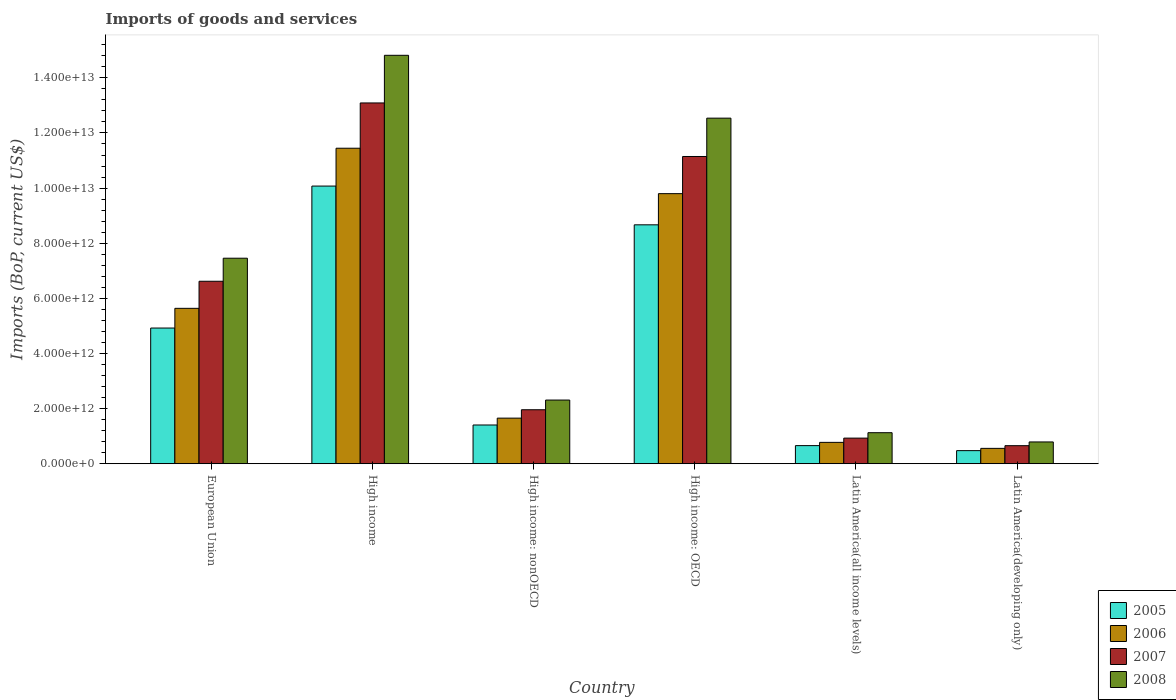How many groups of bars are there?
Provide a succinct answer. 6. Are the number of bars per tick equal to the number of legend labels?
Make the answer very short. Yes. How many bars are there on the 6th tick from the right?
Your answer should be very brief. 4. What is the label of the 6th group of bars from the left?
Keep it short and to the point. Latin America(developing only). What is the amount spent on imports in 2006 in European Union?
Keep it short and to the point. 5.64e+12. Across all countries, what is the maximum amount spent on imports in 2008?
Offer a terse response. 1.48e+13. Across all countries, what is the minimum amount spent on imports in 2005?
Ensure brevity in your answer.  4.75e+11. In which country was the amount spent on imports in 2005 minimum?
Your response must be concise. Latin America(developing only). What is the total amount spent on imports in 2008 in the graph?
Offer a very short reply. 3.90e+13. What is the difference between the amount spent on imports in 2005 in High income: OECD and that in Latin America(all income levels)?
Ensure brevity in your answer.  8.01e+12. What is the difference between the amount spent on imports in 2008 in High income: nonOECD and the amount spent on imports in 2006 in Latin America(developing only)?
Give a very brief answer. 1.75e+12. What is the average amount spent on imports in 2005 per country?
Provide a succinct answer. 4.37e+12. What is the difference between the amount spent on imports of/in 2007 and amount spent on imports of/in 2008 in High income?
Offer a terse response. -1.73e+12. What is the ratio of the amount spent on imports in 2008 in European Union to that in High income: nonOECD?
Offer a very short reply. 3.23. What is the difference between the highest and the second highest amount spent on imports in 2008?
Offer a very short reply. 7.36e+12. What is the difference between the highest and the lowest amount spent on imports in 2007?
Provide a short and direct response. 1.24e+13. What does the 1st bar from the left in Latin America(developing only) represents?
Offer a terse response. 2005. How many countries are there in the graph?
Your answer should be very brief. 6. What is the difference between two consecutive major ticks on the Y-axis?
Keep it short and to the point. 2.00e+12. Does the graph contain any zero values?
Give a very brief answer. No. How are the legend labels stacked?
Your answer should be compact. Vertical. What is the title of the graph?
Your answer should be very brief. Imports of goods and services. Does "1988" appear as one of the legend labels in the graph?
Offer a terse response. No. What is the label or title of the Y-axis?
Ensure brevity in your answer.  Imports (BoP, current US$). What is the Imports (BoP, current US$) of 2005 in European Union?
Your answer should be compact. 4.92e+12. What is the Imports (BoP, current US$) in 2006 in European Union?
Your response must be concise. 5.64e+12. What is the Imports (BoP, current US$) of 2007 in European Union?
Your answer should be very brief. 6.62e+12. What is the Imports (BoP, current US$) in 2008 in European Union?
Provide a succinct answer. 7.46e+12. What is the Imports (BoP, current US$) of 2005 in High income?
Offer a terse response. 1.01e+13. What is the Imports (BoP, current US$) in 2006 in High income?
Ensure brevity in your answer.  1.14e+13. What is the Imports (BoP, current US$) of 2007 in High income?
Provide a succinct answer. 1.31e+13. What is the Imports (BoP, current US$) in 2008 in High income?
Make the answer very short. 1.48e+13. What is the Imports (BoP, current US$) of 2005 in High income: nonOECD?
Provide a succinct answer. 1.41e+12. What is the Imports (BoP, current US$) in 2006 in High income: nonOECD?
Provide a short and direct response. 1.65e+12. What is the Imports (BoP, current US$) in 2007 in High income: nonOECD?
Make the answer very short. 1.96e+12. What is the Imports (BoP, current US$) in 2008 in High income: nonOECD?
Your answer should be compact. 2.31e+12. What is the Imports (BoP, current US$) in 2005 in High income: OECD?
Offer a terse response. 8.67e+12. What is the Imports (BoP, current US$) in 2006 in High income: OECD?
Provide a short and direct response. 9.80e+12. What is the Imports (BoP, current US$) of 2007 in High income: OECD?
Your answer should be compact. 1.11e+13. What is the Imports (BoP, current US$) in 2008 in High income: OECD?
Make the answer very short. 1.25e+13. What is the Imports (BoP, current US$) of 2005 in Latin America(all income levels)?
Keep it short and to the point. 6.57e+11. What is the Imports (BoP, current US$) of 2006 in Latin America(all income levels)?
Make the answer very short. 7.75e+11. What is the Imports (BoP, current US$) in 2007 in Latin America(all income levels)?
Make the answer very short. 9.30e+11. What is the Imports (BoP, current US$) in 2008 in Latin America(all income levels)?
Provide a succinct answer. 1.13e+12. What is the Imports (BoP, current US$) in 2005 in Latin America(developing only)?
Make the answer very short. 4.75e+11. What is the Imports (BoP, current US$) of 2006 in Latin America(developing only)?
Keep it short and to the point. 5.57e+11. What is the Imports (BoP, current US$) in 2007 in Latin America(developing only)?
Your response must be concise. 6.55e+11. What is the Imports (BoP, current US$) of 2008 in Latin America(developing only)?
Offer a very short reply. 7.91e+11. Across all countries, what is the maximum Imports (BoP, current US$) in 2005?
Provide a succinct answer. 1.01e+13. Across all countries, what is the maximum Imports (BoP, current US$) in 2006?
Provide a short and direct response. 1.14e+13. Across all countries, what is the maximum Imports (BoP, current US$) of 2007?
Your response must be concise. 1.31e+13. Across all countries, what is the maximum Imports (BoP, current US$) in 2008?
Make the answer very short. 1.48e+13. Across all countries, what is the minimum Imports (BoP, current US$) of 2005?
Give a very brief answer. 4.75e+11. Across all countries, what is the minimum Imports (BoP, current US$) of 2006?
Make the answer very short. 5.57e+11. Across all countries, what is the minimum Imports (BoP, current US$) in 2007?
Your answer should be very brief. 6.55e+11. Across all countries, what is the minimum Imports (BoP, current US$) in 2008?
Offer a very short reply. 7.91e+11. What is the total Imports (BoP, current US$) of 2005 in the graph?
Make the answer very short. 2.62e+13. What is the total Imports (BoP, current US$) of 2006 in the graph?
Ensure brevity in your answer.  2.99e+13. What is the total Imports (BoP, current US$) in 2007 in the graph?
Ensure brevity in your answer.  3.44e+13. What is the total Imports (BoP, current US$) of 2008 in the graph?
Ensure brevity in your answer.  3.90e+13. What is the difference between the Imports (BoP, current US$) in 2005 in European Union and that in High income?
Provide a succinct answer. -5.15e+12. What is the difference between the Imports (BoP, current US$) in 2006 in European Union and that in High income?
Keep it short and to the point. -5.81e+12. What is the difference between the Imports (BoP, current US$) of 2007 in European Union and that in High income?
Offer a very short reply. -6.47e+12. What is the difference between the Imports (BoP, current US$) of 2008 in European Union and that in High income?
Give a very brief answer. -7.36e+12. What is the difference between the Imports (BoP, current US$) in 2005 in European Union and that in High income: nonOECD?
Offer a terse response. 3.52e+12. What is the difference between the Imports (BoP, current US$) of 2006 in European Union and that in High income: nonOECD?
Keep it short and to the point. 3.98e+12. What is the difference between the Imports (BoP, current US$) in 2007 in European Union and that in High income: nonOECD?
Make the answer very short. 4.66e+12. What is the difference between the Imports (BoP, current US$) of 2008 in European Union and that in High income: nonOECD?
Give a very brief answer. 5.15e+12. What is the difference between the Imports (BoP, current US$) in 2005 in European Union and that in High income: OECD?
Offer a terse response. -3.74e+12. What is the difference between the Imports (BoP, current US$) in 2006 in European Union and that in High income: OECD?
Offer a very short reply. -4.16e+12. What is the difference between the Imports (BoP, current US$) of 2007 in European Union and that in High income: OECD?
Your response must be concise. -4.53e+12. What is the difference between the Imports (BoP, current US$) in 2008 in European Union and that in High income: OECD?
Provide a short and direct response. -5.08e+12. What is the difference between the Imports (BoP, current US$) in 2005 in European Union and that in Latin America(all income levels)?
Offer a very short reply. 4.27e+12. What is the difference between the Imports (BoP, current US$) of 2006 in European Union and that in Latin America(all income levels)?
Provide a succinct answer. 4.86e+12. What is the difference between the Imports (BoP, current US$) of 2007 in European Union and that in Latin America(all income levels)?
Make the answer very short. 5.69e+12. What is the difference between the Imports (BoP, current US$) of 2008 in European Union and that in Latin America(all income levels)?
Keep it short and to the point. 6.33e+12. What is the difference between the Imports (BoP, current US$) in 2005 in European Union and that in Latin America(developing only)?
Provide a short and direct response. 4.45e+12. What is the difference between the Imports (BoP, current US$) in 2006 in European Union and that in Latin America(developing only)?
Offer a very short reply. 5.08e+12. What is the difference between the Imports (BoP, current US$) of 2007 in European Union and that in Latin America(developing only)?
Provide a short and direct response. 5.96e+12. What is the difference between the Imports (BoP, current US$) in 2008 in European Union and that in Latin America(developing only)?
Your response must be concise. 6.67e+12. What is the difference between the Imports (BoP, current US$) of 2005 in High income and that in High income: nonOECD?
Provide a short and direct response. 8.67e+12. What is the difference between the Imports (BoP, current US$) of 2006 in High income and that in High income: nonOECD?
Ensure brevity in your answer.  9.79e+12. What is the difference between the Imports (BoP, current US$) in 2007 in High income and that in High income: nonOECD?
Your answer should be compact. 1.11e+13. What is the difference between the Imports (BoP, current US$) of 2008 in High income and that in High income: nonOECD?
Ensure brevity in your answer.  1.25e+13. What is the difference between the Imports (BoP, current US$) in 2005 in High income and that in High income: OECD?
Offer a terse response. 1.41e+12. What is the difference between the Imports (BoP, current US$) in 2006 in High income and that in High income: OECD?
Your answer should be very brief. 1.65e+12. What is the difference between the Imports (BoP, current US$) of 2007 in High income and that in High income: OECD?
Give a very brief answer. 1.94e+12. What is the difference between the Imports (BoP, current US$) in 2008 in High income and that in High income: OECD?
Ensure brevity in your answer.  2.28e+12. What is the difference between the Imports (BoP, current US$) in 2005 in High income and that in Latin America(all income levels)?
Offer a very short reply. 9.42e+12. What is the difference between the Imports (BoP, current US$) of 2006 in High income and that in Latin America(all income levels)?
Keep it short and to the point. 1.07e+13. What is the difference between the Imports (BoP, current US$) in 2007 in High income and that in Latin America(all income levels)?
Ensure brevity in your answer.  1.22e+13. What is the difference between the Imports (BoP, current US$) of 2008 in High income and that in Latin America(all income levels)?
Make the answer very short. 1.37e+13. What is the difference between the Imports (BoP, current US$) of 2005 in High income and that in Latin America(developing only)?
Offer a very short reply. 9.60e+12. What is the difference between the Imports (BoP, current US$) of 2006 in High income and that in Latin America(developing only)?
Your answer should be very brief. 1.09e+13. What is the difference between the Imports (BoP, current US$) of 2007 in High income and that in Latin America(developing only)?
Provide a short and direct response. 1.24e+13. What is the difference between the Imports (BoP, current US$) of 2008 in High income and that in Latin America(developing only)?
Provide a short and direct response. 1.40e+13. What is the difference between the Imports (BoP, current US$) in 2005 in High income: nonOECD and that in High income: OECD?
Give a very brief answer. -7.26e+12. What is the difference between the Imports (BoP, current US$) of 2006 in High income: nonOECD and that in High income: OECD?
Provide a short and direct response. -8.14e+12. What is the difference between the Imports (BoP, current US$) of 2007 in High income: nonOECD and that in High income: OECD?
Offer a terse response. -9.19e+12. What is the difference between the Imports (BoP, current US$) of 2008 in High income: nonOECD and that in High income: OECD?
Provide a short and direct response. -1.02e+13. What is the difference between the Imports (BoP, current US$) of 2005 in High income: nonOECD and that in Latin America(all income levels)?
Keep it short and to the point. 7.48e+11. What is the difference between the Imports (BoP, current US$) in 2006 in High income: nonOECD and that in Latin America(all income levels)?
Make the answer very short. 8.79e+11. What is the difference between the Imports (BoP, current US$) in 2007 in High income: nonOECD and that in Latin America(all income levels)?
Your answer should be very brief. 1.03e+12. What is the difference between the Imports (BoP, current US$) of 2008 in High income: nonOECD and that in Latin America(all income levels)?
Keep it short and to the point. 1.18e+12. What is the difference between the Imports (BoP, current US$) in 2005 in High income: nonOECD and that in Latin America(developing only)?
Provide a succinct answer. 9.30e+11. What is the difference between the Imports (BoP, current US$) of 2006 in High income: nonOECD and that in Latin America(developing only)?
Offer a terse response. 1.10e+12. What is the difference between the Imports (BoP, current US$) of 2007 in High income: nonOECD and that in Latin America(developing only)?
Offer a terse response. 1.30e+12. What is the difference between the Imports (BoP, current US$) in 2008 in High income: nonOECD and that in Latin America(developing only)?
Provide a short and direct response. 1.52e+12. What is the difference between the Imports (BoP, current US$) in 2005 in High income: OECD and that in Latin America(all income levels)?
Your answer should be compact. 8.01e+12. What is the difference between the Imports (BoP, current US$) of 2006 in High income: OECD and that in Latin America(all income levels)?
Offer a very short reply. 9.02e+12. What is the difference between the Imports (BoP, current US$) in 2007 in High income: OECD and that in Latin America(all income levels)?
Make the answer very short. 1.02e+13. What is the difference between the Imports (BoP, current US$) of 2008 in High income: OECD and that in Latin America(all income levels)?
Ensure brevity in your answer.  1.14e+13. What is the difference between the Imports (BoP, current US$) of 2005 in High income: OECD and that in Latin America(developing only)?
Make the answer very short. 8.19e+12. What is the difference between the Imports (BoP, current US$) of 2006 in High income: OECD and that in Latin America(developing only)?
Keep it short and to the point. 9.24e+12. What is the difference between the Imports (BoP, current US$) of 2007 in High income: OECD and that in Latin America(developing only)?
Provide a short and direct response. 1.05e+13. What is the difference between the Imports (BoP, current US$) in 2008 in High income: OECD and that in Latin America(developing only)?
Your response must be concise. 1.17e+13. What is the difference between the Imports (BoP, current US$) of 2005 in Latin America(all income levels) and that in Latin America(developing only)?
Your answer should be very brief. 1.82e+11. What is the difference between the Imports (BoP, current US$) in 2006 in Latin America(all income levels) and that in Latin America(developing only)?
Ensure brevity in your answer.  2.18e+11. What is the difference between the Imports (BoP, current US$) of 2007 in Latin America(all income levels) and that in Latin America(developing only)?
Offer a very short reply. 2.75e+11. What is the difference between the Imports (BoP, current US$) of 2008 in Latin America(all income levels) and that in Latin America(developing only)?
Keep it short and to the point. 3.35e+11. What is the difference between the Imports (BoP, current US$) in 2005 in European Union and the Imports (BoP, current US$) in 2006 in High income?
Give a very brief answer. -6.52e+12. What is the difference between the Imports (BoP, current US$) in 2005 in European Union and the Imports (BoP, current US$) in 2007 in High income?
Your answer should be very brief. -8.17e+12. What is the difference between the Imports (BoP, current US$) in 2005 in European Union and the Imports (BoP, current US$) in 2008 in High income?
Your answer should be compact. -9.89e+12. What is the difference between the Imports (BoP, current US$) in 2006 in European Union and the Imports (BoP, current US$) in 2007 in High income?
Your answer should be compact. -7.45e+12. What is the difference between the Imports (BoP, current US$) of 2006 in European Union and the Imports (BoP, current US$) of 2008 in High income?
Offer a very short reply. -9.18e+12. What is the difference between the Imports (BoP, current US$) of 2007 in European Union and the Imports (BoP, current US$) of 2008 in High income?
Your answer should be very brief. -8.20e+12. What is the difference between the Imports (BoP, current US$) in 2005 in European Union and the Imports (BoP, current US$) in 2006 in High income: nonOECD?
Your response must be concise. 3.27e+12. What is the difference between the Imports (BoP, current US$) of 2005 in European Union and the Imports (BoP, current US$) of 2007 in High income: nonOECD?
Offer a terse response. 2.96e+12. What is the difference between the Imports (BoP, current US$) of 2005 in European Union and the Imports (BoP, current US$) of 2008 in High income: nonOECD?
Keep it short and to the point. 2.61e+12. What is the difference between the Imports (BoP, current US$) of 2006 in European Union and the Imports (BoP, current US$) of 2007 in High income: nonOECD?
Your response must be concise. 3.68e+12. What is the difference between the Imports (BoP, current US$) of 2006 in European Union and the Imports (BoP, current US$) of 2008 in High income: nonOECD?
Give a very brief answer. 3.33e+12. What is the difference between the Imports (BoP, current US$) of 2007 in European Union and the Imports (BoP, current US$) of 2008 in High income: nonOECD?
Give a very brief answer. 4.31e+12. What is the difference between the Imports (BoP, current US$) in 2005 in European Union and the Imports (BoP, current US$) in 2006 in High income: OECD?
Keep it short and to the point. -4.88e+12. What is the difference between the Imports (BoP, current US$) of 2005 in European Union and the Imports (BoP, current US$) of 2007 in High income: OECD?
Your answer should be compact. -6.22e+12. What is the difference between the Imports (BoP, current US$) of 2005 in European Union and the Imports (BoP, current US$) of 2008 in High income: OECD?
Offer a very short reply. -7.61e+12. What is the difference between the Imports (BoP, current US$) in 2006 in European Union and the Imports (BoP, current US$) in 2007 in High income: OECD?
Make the answer very short. -5.51e+12. What is the difference between the Imports (BoP, current US$) of 2006 in European Union and the Imports (BoP, current US$) of 2008 in High income: OECD?
Offer a terse response. -6.90e+12. What is the difference between the Imports (BoP, current US$) in 2007 in European Union and the Imports (BoP, current US$) in 2008 in High income: OECD?
Provide a short and direct response. -5.92e+12. What is the difference between the Imports (BoP, current US$) in 2005 in European Union and the Imports (BoP, current US$) in 2006 in Latin America(all income levels)?
Ensure brevity in your answer.  4.15e+12. What is the difference between the Imports (BoP, current US$) of 2005 in European Union and the Imports (BoP, current US$) of 2007 in Latin America(all income levels)?
Offer a very short reply. 3.99e+12. What is the difference between the Imports (BoP, current US$) in 2005 in European Union and the Imports (BoP, current US$) in 2008 in Latin America(all income levels)?
Your answer should be compact. 3.80e+12. What is the difference between the Imports (BoP, current US$) in 2006 in European Union and the Imports (BoP, current US$) in 2007 in Latin America(all income levels)?
Offer a very short reply. 4.71e+12. What is the difference between the Imports (BoP, current US$) of 2006 in European Union and the Imports (BoP, current US$) of 2008 in Latin America(all income levels)?
Give a very brief answer. 4.51e+12. What is the difference between the Imports (BoP, current US$) of 2007 in European Union and the Imports (BoP, current US$) of 2008 in Latin America(all income levels)?
Offer a very short reply. 5.49e+12. What is the difference between the Imports (BoP, current US$) of 2005 in European Union and the Imports (BoP, current US$) of 2006 in Latin America(developing only)?
Provide a succinct answer. 4.37e+12. What is the difference between the Imports (BoP, current US$) of 2005 in European Union and the Imports (BoP, current US$) of 2007 in Latin America(developing only)?
Provide a short and direct response. 4.27e+12. What is the difference between the Imports (BoP, current US$) in 2005 in European Union and the Imports (BoP, current US$) in 2008 in Latin America(developing only)?
Offer a terse response. 4.13e+12. What is the difference between the Imports (BoP, current US$) in 2006 in European Union and the Imports (BoP, current US$) in 2007 in Latin America(developing only)?
Keep it short and to the point. 4.98e+12. What is the difference between the Imports (BoP, current US$) of 2006 in European Union and the Imports (BoP, current US$) of 2008 in Latin America(developing only)?
Offer a very short reply. 4.85e+12. What is the difference between the Imports (BoP, current US$) of 2007 in European Union and the Imports (BoP, current US$) of 2008 in Latin America(developing only)?
Your answer should be compact. 5.83e+12. What is the difference between the Imports (BoP, current US$) in 2005 in High income and the Imports (BoP, current US$) in 2006 in High income: nonOECD?
Provide a succinct answer. 8.42e+12. What is the difference between the Imports (BoP, current US$) in 2005 in High income and the Imports (BoP, current US$) in 2007 in High income: nonOECD?
Offer a terse response. 8.11e+12. What is the difference between the Imports (BoP, current US$) of 2005 in High income and the Imports (BoP, current US$) of 2008 in High income: nonOECD?
Offer a terse response. 7.76e+12. What is the difference between the Imports (BoP, current US$) of 2006 in High income and the Imports (BoP, current US$) of 2007 in High income: nonOECD?
Your answer should be compact. 9.49e+12. What is the difference between the Imports (BoP, current US$) of 2006 in High income and the Imports (BoP, current US$) of 2008 in High income: nonOECD?
Your answer should be compact. 9.14e+12. What is the difference between the Imports (BoP, current US$) in 2007 in High income and the Imports (BoP, current US$) in 2008 in High income: nonOECD?
Provide a short and direct response. 1.08e+13. What is the difference between the Imports (BoP, current US$) of 2005 in High income and the Imports (BoP, current US$) of 2006 in High income: OECD?
Offer a terse response. 2.75e+11. What is the difference between the Imports (BoP, current US$) of 2005 in High income and the Imports (BoP, current US$) of 2007 in High income: OECD?
Offer a terse response. -1.07e+12. What is the difference between the Imports (BoP, current US$) in 2005 in High income and the Imports (BoP, current US$) in 2008 in High income: OECD?
Your response must be concise. -2.46e+12. What is the difference between the Imports (BoP, current US$) of 2006 in High income and the Imports (BoP, current US$) of 2007 in High income: OECD?
Provide a succinct answer. 3.00e+11. What is the difference between the Imports (BoP, current US$) in 2006 in High income and the Imports (BoP, current US$) in 2008 in High income: OECD?
Give a very brief answer. -1.09e+12. What is the difference between the Imports (BoP, current US$) of 2007 in High income and the Imports (BoP, current US$) of 2008 in High income: OECD?
Give a very brief answer. 5.51e+11. What is the difference between the Imports (BoP, current US$) of 2005 in High income and the Imports (BoP, current US$) of 2006 in Latin America(all income levels)?
Offer a very short reply. 9.30e+12. What is the difference between the Imports (BoP, current US$) in 2005 in High income and the Imports (BoP, current US$) in 2007 in Latin America(all income levels)?
Your response must be concise. 9.14e+12. What is the difference between the Imports (BoP, current US$) of 2005 in High income and the Imports (BoP, current US$) of 2008 in Latin America(all income levels)?
Your answer should be very brief. 8.95e+12. What is the difference between the Imports (BoP, current US$) of 2006 in High income and the Imports (BoP, current US$) of 2007 in Latin America(all income levels)?
Provide a succinct answer. 1.05e+13. What is the difference between the Imports (BoP, current US$) of 2006 in High income and the Imports (BoP, current US$) of 2008 in Latin America(all income levels)?
Make the answer very short. 1.03e+13. What is the difference between the Imports (BoP, current US$) of 2007 in High income and the Imports (BoP, current US$) of 2008 in Latin America(all income levels)?
Provide a short and direct response. 1.20e+13. What is the difference between the Imports (BoP, current US$) in 2005 in High income and the Imports (BoP, current US$) in 2006 in Latin America(developing only)?
Your answer should be very brief. 9.52e+12. What is the difference between the Imports (BoP, current US$) in 2005 in High income and the Imports (BoP, current US$) in 2007 in Latin America(developing only)?
Your answer should be compact. 9.42e+12. What is the difference between the Imports (BoP, current US$) of 2005 in High income and the Imports (BoP, current US$) of 2008 in Latin America(developing only)?
Give a very brief answer. 9.28e+12. What is the difference between the Imports (BoP, current US$) of 2006 in High income and the Imports (BoP, current US$) of 2007 in Latin America(developing only)?
Provide a succinct answer. 1.08e+13. What is the difference between the Imports (BoP, current US$) in 2006 in High income and the Imports (BoP, current US$) in 2008 in Latin America(developing only)?
Provide a succinct answer. 1.07e+13. What is the difference between the Imports (BoP, current US$) of 2007 in High income and the Imports (BoP, current US$) of 2008 in Latin America(developing only)?
Your response must be concise. 1.23e+13. What is the difference between the Imports (BoP, current US$) of 2005 in High income: nonOECD and the Imports (BoP, current US$) of 2006 in High income: OECD?
Your answer should be compact. -8.39e+12. What is the difference between the Imports (BoP, current US$) of 2005 in High income: nonOECD and the Imports (BoP, current US$) of 2007 in High income: OECD?
Ensure brevity in your answer.  -9.74e+12. What is the difference between the Imports (BoP, current US$) in 2005 in High income: nonOECD and the Imports (BoP, current US$) in 2008 in High income: OECD?
Ensure brevity in your answer.  -1.11e+13. What is the difference between the Imports (BoP, current US$) in 2006 in High income: nonOECD and the Imports (BoP, current US$) in 2007 in High income: OECD?
Give a very brief answer. -9.49e+12. What is the difference between the Imports (BoP, current US$) of 2006 in High income: nonOECD and the Imports (BoP, current US$) of 2008 in High income: OECD?
Provide a short and direct response. -1.09e+13. What is the difference between the Imports (BoP, current US$) of 2007 in High income: nonOECD and the Imports (BoP, current US$) of 2008 in High income: OECD?
Keep it short and to the point. -1.06e+13. What is the difference between the Imports (BoP, current US$) of 2005 in High income: nonOECD and the Imports (BoP, current US$) of 2006 in Latin America(all income levels)?
Ensure brevity in your answer.  6.30e+11. What is the difference between the Imports (BoP, current US$) of 2005 in High income: nonOECD and the Imports (BoP, current US$) of 2007 in Latin America(all income levels)?
Your answer should be compact. 4.76e+11. What is the difference between the Imports (BoP, current US$) in 2005 in High income: nonOECD and the Imports (BoP, current US$) in 2008 in Latin America(all income levels)?
Ensure brevity in your answer.  2.79e+11. What is the difference between the Imports (BoP, current US$) of 2006 in High income: nonOECD and the Imports (BoP, current US$) of 2007 in Latin America(all income levels)?
Offer a very short reply. 7.25e+11. What is the difference between the Imports (BoP, current US$) of 2006 in High income: nonOECD and the Imports (BoP, current US$) of 2008 in Latin America(all income levels)?
Your answer should be compact. 5.28e+11. What is the difference between the Imports (BoP, current US$) in 2007 in High income: nonOECD and the Imports (BoP, current US$) in 2008 in Latin America(all income levels)?
Offer a terse response. 8.33e+11. What is the difference between the Imports (BoP, current US$) in 2005 in High income: nonOECD and the Imports (BoP, current US$) in 2006 in Latin America(developing only)?
Keep it short and to the point. 8.48e+11. What is the difference between the Imports (BoP, current US$) in 2005 in High income: nonOECD and the Imports (BoP, current US$) in 2007 in Latin America(developing only)?
Ensure brevity in your answer.  7.50e+11. What is the difference between the Imports (BoP, current US$) of 2005 in High income: nonOECD and the Imports (BoP, current US$) of 2008 in Latin America(developing only)?
Offer a terse response. 6.15e+11. What is the difference between the Imports (BoP, current US$) in 2006 in High income: nonOECD and the Imports (BoP, current US$) in 2007 in Latin America(developing only)?
Make the answer very short. 9.99e+11. What is the difference between the Imports (BoP, current US$) in 2006 in High income: nonOECD and the Imports (BoP, current US$) in 2008 in Latin America(developing only)?
Your response must be concise. 8.64e+11. What is the difference between the Imports (BoP, current US$) of 2007 in High income: nonOECD and the Imports (BoP, current US$) of 2008 in Latin America(developing only)?
Your answer should be compact. 1.17e+12. What is the difference between the Imports (BoP, current US$) in 2005 in High income: OECD and the Imports (BoP, current US$) in 2006 in Latin America(all income levels)?
Provide a succinct answer. 7.89e+12. What is the difference between the Imports (BoP, current US$) in 2005 in High income: OECD and the Imports (BoP, current US$) in 2007 in Latin America(all income levels)?
Ensure brevity in your answer.  7.74e+12. What is the difference between the Imports (BoP, current US$) of 2005 in High income: OECD and the Imports (BoP, current US$) of 2008 in Latin America(all income levels)?
Your response must be concise. 7.54e+12. What is the difference between the Imports (BoP, current US$) of 2006 in High income: OECD and the Imports (BoP, current US$) of 2007 in Latin America(all income levels)?
Offer a terse response. 8.87e+12. What is the difference between the Imports (BoP, current US$) in 2006 in High income: OECD and the Imports (BoP, current US$) in 2008 in Latin America(all income levels)?
Give a very brief answer. 8.67e+12. What is the difference between the Imports (BoP, current US$) in 2007 in High income: OECD and the Imports (BoP, current US$) in 2008 in Latin America(all income levels)?
Make the answer very short. 1.00e+13. What is the difference between the Imports (BoP, current US$) of 2005 in High income: OECD and the Imports (BoP, current US$) of 2006 in Latin America(developing only)?
Offer a terse response. 8.11e+12. What is the difference between the Imports (BoP, current US$) of 2005 in High income: OECD and the Imports (BoP, current US$) of 2007 in Latin America(developing only)?
Keep it short and to the point. 8.01e+12. What is the difference between the Imports (BoP, current US$) in 2005 in High income: OECD and the Imports (BoP, current US$) in 2008 in Latin America(developing only)?
Offer a very short reply. 7.88e+12. What is the difference between the Imports (BoP, current US$) in 2006 in High income: OECD and the Imports (BoP, current US$) in 2007 in Latin America(developing only)?
Offer a very short reply. 9.14e+12. What is the difference between the Imports (BoP, current US$) of 2006 in High income: OECD and the Imports (BoP, current US$) of 2008 in Latin America(developing only)?
Ensure brevity in your answer.  9.01e+12. What is the difference between the Imports (BoP, current US$) in 2007 in High income: OECD and the Imports (BoP, current US$) in 2008 in Latin America(developing only)?
Give a very brief answer. 1.04e+13. What is the difference between the Imports (BoP, current US$) in 2005 in Latin America(all income levels) and the Imports (BoP, current US$) in 2006 in Latin America(developing only)?
Give a very brief answer. 9.99e+1. What is the difference between the Imports (BoP, current US$) of 2005 in Latin America(all income levels) and the Imports (BoP, current US$) of 2007 in Latin America(developing only)?
Make the answer very short. 2.04e+09. What is the difference between the Imports (BoP, current US$) in 2005 in Latin America(all income levels) and the Imports (BoP, current US$) in 2008 in Latin America(developing only)?
Your answer should be compact. -1.33e+11. What is the difference between the Imports (BoP, current US$) in 2006 in Latin America(all income levels) and the Imports (BoP, current US$) in 2007 in Latin America(developing only)?
Ensure brevity in your answer.  1.20e+11. What is the difference between the Imports (BoP, current US$) of 2006 in Latin America(all income levels) and the Imports (BoP, current US$) of 2008 in Latin America(developing only)?
Your answer should be very brief. -1.55e+1. What is the difference between the Imports (BoP, current US$) of 2007 in Latin America(all income levels) and the Imports (BoP, current US$) of 2008 in Latin America(developing only)?
Make the answer very short. 1.39e+11. What is the average Imports (BoP, current US$) in 2005 per country?
Provide a succinct answer. 4.37e+12. What is the average Imports (BoP, current US$) of 2006 per country?
Your answer should be compact. 4.98e+12. What is the average Imports (BoP, current US$) in 2007 per country?
Give a very brief answer. 5.73e+12. What is the average Imports (BoP, current US$) in 2008 per country?
Offer a very short reply. 6.51e+12. What is the difference between the Imports (BoP, current US$) in 2005 and Imports (BoP, current US$) in 2006 in European Union?
Your answer should be compact. -7.15e+11. What is the difference between the Imports (BoP, current US$) in 2005 and Imports (BoP, current US$) in 2007 in European Union?
Provide a succinct answer. -1.70e+12. What is the difference between the Imports (BoP, current US$) of 2005 and Imports (BoP, current US$) of 2008 in European Union?
Make the answer very short. -2.53e+12. What is the difference between the Imports (BoP, current US$) of 2006 and Imports (BoP, current US$) of 2007 in European Union?
Your response must be concise. -9.82e+11. What is the difference between the Imports (BoP, current US$) of 2006 and Imports (BoP, current US$) of 2008 in European Union?
Offer a very short reply. -1.82e+12. What is the difference between the Imports (BoP, current US$) of 2007 and Imports (BoP, current US$) of 2008 in European Union?
Your answer should be compact. -8.37e+11. What is the difference between the Imports (BoP, current US$) in 2005 and Imports (BoP, current US$) in 2006 in High income?
Offer a terse response. -1.37e+12. What is the difference between the Imports (BoP, current US$) of 2005 and Imports (BoP, current US$) of 2007 in High income?
Ensure brevity in your answer.  -3.02e+12. What is the difference between the Imports (BoP, current US$) in 2005 and Imports (BoP, current US$) in 2008 in High income?
Provide a short and direct response. -4.74e+12. What is the difference between the Imports (BoP, current US$) of 2006 and Imports (BoP, current US$) of 2007 in High income?
Make the answer very short. -1.64e+12. What is the difference between the Imports (BoP, current US$) in 2006 and Imports (BoP, current US$) in 2008 in High income?
Provide a succinct answer. -3.37e+12. What is the difference between the Imports (BoP, current US$) in 2007 and Imports (BoP, current US$) in 2008 in High income?
Your answer should be compact. -1.73e+12. What is the difference between the Imports (BoP, current US$) in 2005 and Imports (BoP, current US$) in 2006 in High income: nonOECD?
Provide a short and direct response. -2.49e+11. What is the difference between the Imports (BoP, current US$) in 2005 and Imports (BoP, current US$) in 2007 in High income: nonOECD?
Make the answer very short. -5.53e+11. What is the difference between the Imports (BoP, current US$) of 2005 and Imports (BoP, current US$) of 2008 in High income: nonOECD?
Keep it short and to the point. -9.05e+11. What is the difference between the Imports (BoP, current US$) of 2006 and Imports (BoP, current US$) of 2007 in High income: nonOECD?
Make the answer very short. -3.04e+11. What is the difference between the Imports (BoP, current US$) in 2006 and Imports (BoP, current US$) in 2008 in High income: nonOECD?
Offer a terse response. -6.56e+11. What is the difference between the Imports (BoP, current US$) in 2007 and Imports (BoP, current US$) in 2008 in High income: nonOECD?
Make the answer very short. -3.51e+11. What is the difference between the Imports (BoP, current US$) of 2005 and Imports (BoP, current US$) of 2006 in High income: OECD?
Give a very brief answer. -1.13e+12. What is the difference between the Imports (BoP, current US$) in 2005 and Imports (BoP, current US$) in 2007 in High income: OECD?
Provide a succinct answer. -2.48e+12. What is the difference between the Imports (BoP, current US$) in 2005 and Imports (BoP, current US$) in 2008 in High income: OECD?
Make the answer very short. -3.87e+12. What is the difference between the Imports (BoP, current US$) in 2006 and Imports (BoP, current US$) in 2007 in High income: OECD?
Your answer should be very brief. -1.35e+12. What is the difference between the Imports (BoP, current US$) of 2006 and Imports (BoP, current US$) of 2008 in High income: OECD?
Provide a succinct answer. -2.74e+12. What is the difference between the Imports (BoP, current US$) in 2007 and Imports (BoP, current US$) in 2008 in High income: OECD?
Offer a terse response. -1.39e+12. What is the difference between the Imports (BoP, current US$) in 2005 and Imports (BoP, current US$) in 2006 in Latin America(all income levels)?
Make the answer very short. -1.18e+11. What is the difference between the Imports (BoP, current US$) of 2005 and Imports (BoP, current US$) of 2007 in Latin America(all income levels)?
Offer a very short reply. -2.72e+11. What is the difference between the Imports (BoP, current US$) of 2005 and Imports (BoP, current US$) of 2008 in Latin America(all income levels)?
Keep it short and to the point. -4.69e+11. What is the difference between the Imports (BoP, current US$) in 2006 and Imports (BoP, current US$) in 2007 in Latin America(all income levels)?
Offer a terse response. -1.54e+11. What is the difference between the Imports (BoP, current US$) of 2006 and Imports (BoP, current US$) of 2008 in Latin America(all income levels)?
Offer a terse response. -3.51e+11. What is the difference between the Imports (BoP, current US$) of 2007 and Imports (BoP, current US$) of 2008 in Latin America(all income levels)?
Offer a terse response. -1.96e+11. What is the difference between the Imports (BoP, current US$) of 2005 and Imports (BoP, current US$) of 2006 in Latin America(developing only)?
Your response must be concise. -8.20e+1. What is the difference between the Imports (BoP, current US$) in 2005 and Imports (BoP, current US$) in 2007 in Latin America(developing only)?
Your answer should be very brief. -1.80e+11. What is the difference between the Imports (BoP, current US$) in 2005 and Imports (BoP, current US$) in 2008 in Latin America(developing only)?
Give a very brief answer. -3.15e+11. What is the difference between the Imports (BoP, current US$) of 2006 and Imports (BoP, current US$) of 2007 in Latin America(developing only)?
Provide a short and direct response. -9.79e+1. What is the difference between the Imports (BoP, current US$) in 2006 and Imports (BoP, current US$) in 2008 in Latin America(developing only)?
Ensure brevity in your answer.  -2.33e+11. What is the difference between the Imports (BoP, current US$) in 2007 and Imports (BoP, current US$) in 2008 in Latin America(developing only)?
Your answer should be compact. -1.36e+11. What is the ratio of the Imports (BoP, current US$) in 2005 in European Union to that in High income?
Provide a short and direct response. 0.49. What is the ratio of the Imports (BoP, current US$) of 2006 in European Union to that in High income?
Provide a short and direct response. 0.49. What is the ratio of the Imports (BoP, current US$) of 2007 in European Union to that in High income?
Your answer should be compact. 0.51. What is the ratio of the Imports (BoP, current US$) of 2008 in European Union to that in High income?
Provide a succinct answer. 0.5. What is the ratio of the Imports (BoP, current US$) of 2005 in European Union to that in High income: nonOECD?
Keep it short and to the point. 3.5. What is the ratio of the Imports (BoP, current US$) in 2006 in European Union to that in High income: nonOECD?
Your response must be concise. 3.41. What is the ratio of the Imports (BoP, current US$) of 2007 in European Union to that in High income: nonOECD?
Keep it short and to the point. 3.38. What is the ratio of the Imports (BoP, current US$) of 2008 in European Union to that in High income: nonOECD?
Offer a terse response. 3.23. What is the ratio of the Imports (BoP, current US$) of 2005 in European Union to that in High income: OECD?
Ensure brevity in your answer.  0.57. What is the ratio of the Imports (BoP, current US$) of 2006 in European Union to that in High income: OECD?
Ensure brevity in your answer.  0.58. What is the ratio of the Imports (BoP, current US$) of 2007 in European Union to that in High income: OECD?
Your answer should be compact. 0.59. What is the ratio of the Imports (BoP, current US$) of 2008 in European Union to that in High income: OECD?
Offer a terse response. 0.59. What is the ratio of the Imports (BoP, current US$) of 2005 in European Union to that in Latin America(all income levels)?
Provide a short and direct response. 7.49. What is the ratio of the Imports (BoP, current US$) of 2006 in European Union to that in Latin America(all income levels)?
Give a very brief answer. 7.27. What is the ratio of the Imports (BoP, current US$) in 2007 in European Union to that in Latin America(all income levels)?
Offer a very short reply. 7.12. What is the ratio of the Imports (BoP, current US$) of 2008 in European Union to that in Latin America(all income levels)?
Offer a very short reply. 6.62. What is the ratio of the Imports (BoP, current US$) in 2005 in European Union to that in Latin America(developing only)?
Offer a very short reply. 10.36. What is the ratio of the Imports (BoP, current US$) of 2006 in European Union to that in Latin America(developing only)?
Offer a terse response. 10.11. What is the ratio of the Imports (BoP, current US$) in 2007 in European Union to that in Latin America(developing only)?
Make the answer very short. 10.1. What is the ratio of the Imports (BoP, current US$) in 2008 in European Union to that in Latin America(developing only)?
Ensure brevity in your answer.  9.43. What is the ratio of the Imports (BoP, current US$) in 2005 in High income to that in High income: nonOECD?
Provide a short and direct response. 7.17. What is the ratio of the Imports (BoP, current US$) of 2006 in High income to that in High income: nonOECD?
Offer a very short reply. 6.92. What is the ratio of the Imports (BoP, current US$) in 2007 in High income to that in High income: nonOECD?
Your answer should be compact. 6.68. What is the ratio of the Imports (BoP, current US$) in 2008 in High income to that in High income: nonOECD?
Keep it short and to the point. 6.41. What is the ratio of the Imports (BoP, current US$) in 2005 in High income to that in High income: OECD?
Your answer should be very brief. 1.16. What is the ratio of the Imports (BoP, current US$) in 2006 in High income to that in High income: OECD?
Your answer should be very brief. 1.17. What is the ratio of the Imports (BoP, current US$) of 2007 in High income to that in High income: OECD?
Offer a terse response. 1.17. What is the ratio of the Imports (BoP, current US$) of 2008 in High income to that in High income: OECD?
Your answer should be very brief. 1.18. What is the ratio of the Imports (BoP, current US$) in 2005 in High income to that in Latin America(all income levels)?
Your response must be concise. 15.33. What is the ratio of the Imports (BoP, current US$) of 2006 in High income to that in Latin America(all income levels)?
Provide a succinct answer. 14.76. What is the ratio of the Imports (BoP, current US$) of 2007 in High income to that in Latin America(all income levels)?
Give a very brief answer. 14.08. What is the ratio of the Imports (BoP, current US$) in 2008 in High income to that in Latin America(all income levels)?
Your response must be concise. 13.16. What is the ratio of the Imports (BoP, current US$) in 2005 in High income to that in Latin America(developing only)?
Offer a terse response. 21.19. What is the ratio of the Imports (BoP, current US$) in 2006 in High income to that in Latin America(developing only)?
Make the answer very short. 20.54. What is the ratio of the Imports (BoP, current US$) in 2007 in High income to that in Latin America(developing only)?
Your answer should be compact. 19.98. What is the ratio of the Imports (BoP, current US$) in 2008 in High income to that in Latin America(developing only)?
Provide a succinct answer. 18.74. What is the ratio of the Imports (BoP, current US$) in 2005 in High income: nonOECD to that in High income: OECD?
Provide a succinct answer. 0.16. What is the ratio of the Imports (BoP, current US$) in 2006 in High income: nonOECD to that in High income: OECD?
Keep it short and to the point. 0.17. What is the ratio of the Imports (BoP, current US$) of 2007 in High income: nonOECD to that in High income: OECD?
Offer a terse response. 0.18. What is the ratio of the Imports (BoP, current US$) in 2008 in High income: nonOECD to that in High income: OECD?
Your answer should be compact. 0.18. What is the ratio of the Imports (BoP, current US$) of 2005 in High income: nonOECD to that in Latin America(all income levels)?
Provide a short and direct response. 2.14. What is the ratio of the Imports (BoP, current US$) of 2006 in High income: nonOECD to that in Latin America(all income levels)?
Your answer should be very brief. 2.13. What is the ratio of the Imports (BoP, current US$) of 2007 in High income: nonOECD to that in Latin America(all income levels)?
Keep it short and to the point. 2.11. What is the ratio of the Imports (BoP, current US$) in 2008 in High income: nonOECD to that in Latin America(all income levels)?
Provide a succinct answer. 2.05. What is the ratio of the Imports (BoP, current US$) of 2005 in High income: nonOECD to that in Latin America(developing only)?
Offer a very short reply. 2.96. What is the ratio of the Imports (BoP, current US$) in 2006 in High income: nonOECD to that in Latin America(developing only)?
Make the answer very short. 2.97. What is the ratio of the Imports (BoP, current US$) in 2007 in High income: nonOECD to that in Latin America(developing only)?
Your answer should be compact. 2.99. What is the ratio of the Imports (BoP, current US$) in 2008 in High income: nonOECD to that in Latin America(developing only)?
Offer a terse response. 2.92. What is the ratio of the Imports (BoP, current US$) of 2005 in High income: OECD to that in Latin America(all income levels)?
Keep it short and to the point. 13.19. What is the ratio of the Imports (BoP, current US$) in 2006 in High income: OECD to that in Latin America(all income levels)?
Provide a short and direct response. 12.64. What is the ratio of the Imports (BoP, current US$) in 2007 in High income: OECD to that in Latin America(all income levels)?
Offer a terse response. 11.99. What is the ratio of the Imports (BoP, current US$) of 2008 in High income: OECD to that in Latin America(all income levels)?
Ensure brevity in your answer.  11.13. What is the ratio of the Imports (BoP, current US$) in 2005 in High income: OECD to that in Latin America(developing only)?
Provide a succinct answer. 18.23. What is the ratio of the Imports (BoP, current US$) of 2006 in High income: OECD to that in Latin America(developing only)?
Offer a terse response. 17.58. What is the ratio of the Imports (BoP, current US$) in 2007 in High income: OECD to that in Latin America(developing only)?
Keep it short and to the point. 17.01. What is the ratio of the Imports (BoP, current US$) in 2008 in High income: OECD to that in Latin America(developing only)?
Your answer should be compact. 15.86. What is the ratio of the Imports (BoP, current US$) in 2005 in Latin America(all income levels) to that in Latin America(developing only)?
Give a very brief answer. 1.38. What is the ratio of the Imports (BoP, current US$) of 2006 in Latin America(all income levels) to that in Latin America(developing only)?
Give a very brief answer. 1.39. What is the ratio of the Imports (BoP, current US$) of 2007 in Latin America(all income levels) to that in Latin America(developing only)?
Your response must be concise. 1.42. What is the ratio of the Imports (BoP, current US$) of 2008 in Latin America(all income levels) to that in Latin America(developing only)?
Provide a succinct answer. 1.42. What is the difference between the highest and the second highest Imports (BoP, current US$) in 2005?
Ensure brevity in your answer.  1.41e+12. What is the difference between the highest and the second highest Imports (BoP, current US$) in 2006?
Your answer should be very brief. 1.65e+12. What is the difference between the highest and the second highest Imports (BoP, current US$) of 2007?
Provide a short and direct response. 1.94e+12. What is the difference between the highest and the second highest Imports (BoP, current US$) in 2008?
Make the answer very short. 2.28e+12. What is the difference between the highest and the lowest Imports (BoP, current US$) in 2005?
Offer a terse response. 9.60e+12. What is the difference between the highest and the lowest Imports (BoP, current US$) in 2006?
Give a very brief answer. 1.09e+13. What is the difference between the highest and the lowest Imports (BoP, current US$) of 2007?
Make the answer very short. 1.24e+13. What is the difference between the highest and the lowest Imports (BoP, current US$) of 2008?
Give a very brief answer. 1.40e+13. 